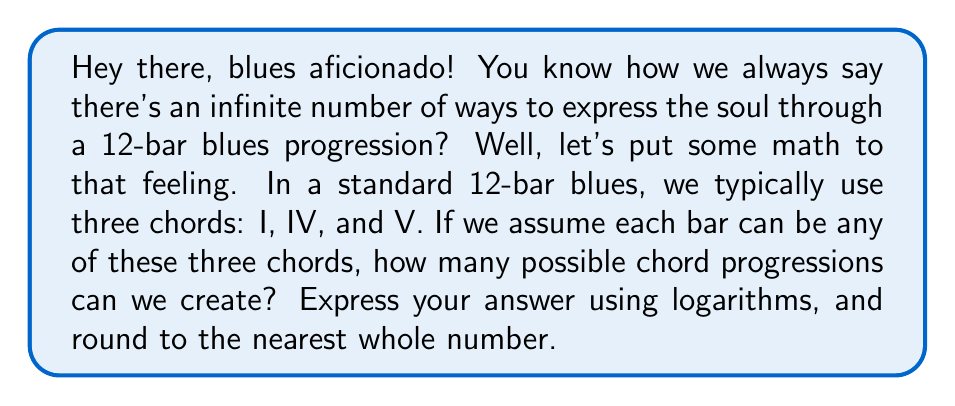Show me your answer to this math problem. Alright, let's break this down like a slow blues:

1) In a 12-bar blues, we have 12 choices to make, one for each bar.

2) For each bar, we have 3 possible choices (I, IV, or V chord).

3) This is a classic case of the multiplication principle. The total number of possibilities is:

   $3 \times 3 \times 3 \times ... \text{ (12 times)} = 3^{12}$

4) Now, we need to express this using logarithms. We can use the property:

   $\log_a(x^n) = n \log_a(x)$

5) Let's use base 10 logarithms for easier calculation:

   $\log_{10}(3^{12}) = 12 \log_{10}(3)$

6) Using a calculator (or feeling it in your bones):

   $12 \log_{10}(3) \approx 12 \times 0.47712125472 \approx 5.72545505664$

7) Remember, $10^{5.72545505664} = 3^{12}$

8) Rounding to the nearest whole number:

   $10^{5.72545505664} \approx 531441$

So, there are approximately 531,441 possible chord progressions in a 12-bar blues using this simplified model.
Answer: $\lfloor 10^{12 \log_{10}(3)} \rceil \approx 531441$ 